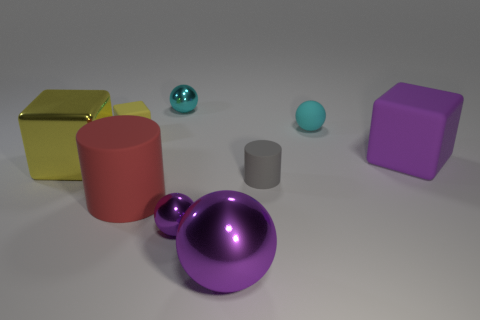What material is the large thing on the right side of the cylinder on the right side of the small cyan ball behind the cyan matte sphere?
Your response must be concise. Rubber. There is a shiny ball behind the tiny gray rubber object; is it the same size as the gray rubber object that is to the right of the big red cylinder?
Your answer should be very brief. Yes. How many other objects are the same material as the large purple sphere?
Provide a succinct answer. 3. How many rubber things are either large blocks or purple objects?
Your answer should be very brief. 1. Is the number of yellow shiny balls less than the number of cylinders?
Give a very brief answer. Yes. Is the size of the red rubber cylinder the same as the matte cube that is to the right of the small gray thing?
Make the answer very short. Yes. Are there any other things that have the same shape as the tiny purple shiny thing?
Make the answer very short. Yes. What is the size of the gray rubber cylinder?
Your answer should be compact. Small. Is the number of large purple cubes that are in front of the gray cylinder less than the number of matte spheres?
Make the answer very short. Yes. Do the cyan metal object and the red object have the same size?
Ensure brevity in your answer.  No. 